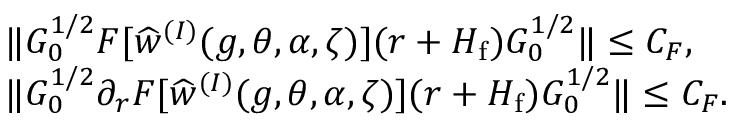<formula> <loc_0><loc_0><loc_500><loc_500>\begin{array} { r l } & { \| G _ { 0 } ^ { 1 / 2 } F [ \widehat { w } ^ { ( I ) } ( g , \theta , \alpha , \zeta ) ] ( r + H _ { f } ) G _ { 0 } ^ { 1 / 2 } \| \leq C _ { F } , } \\ & { \| G _ { 0 } ^ { 1 / 2 } \partial _ { r } F [ \widehat { w } ^ { ( I ) } ( g , \theta , \alpha , \zeta ) ] ( r + H _ { f } ) G _ { 0 } ^ { 1 / 2 } \| \leq C _ { F } . } \end{array}</formula> 